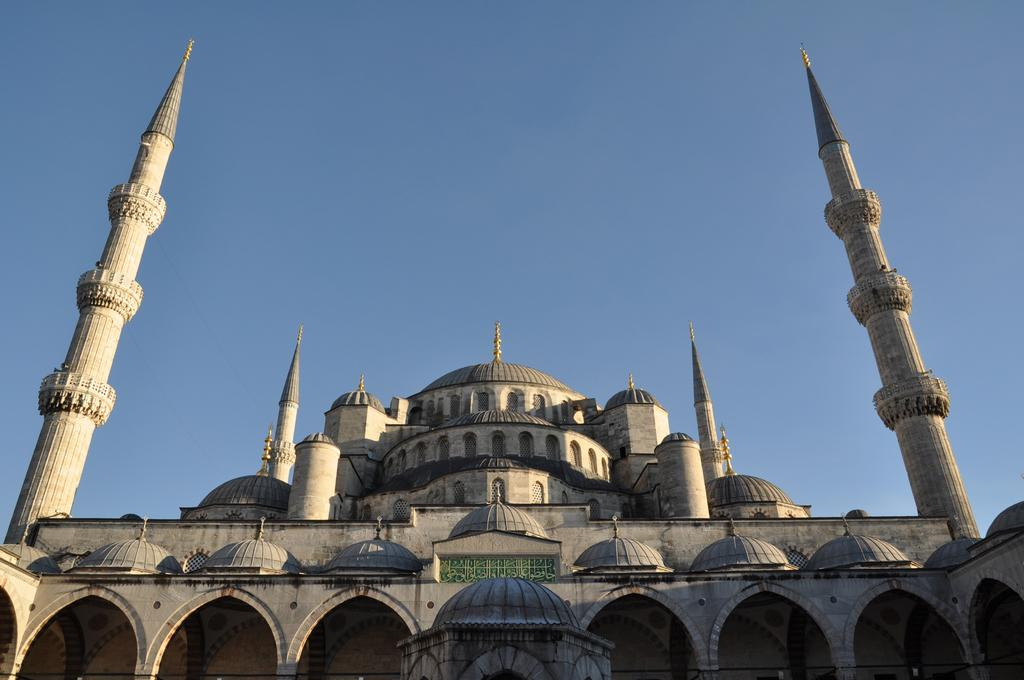What structure is present in the image? There is a building in the image. What part of the natural environment is visible in the image? The sky is visible in the background of the image. What type of voice can be heard coming from the building in the image? There is no indication in the image that any voice can be heard coming from the building. 